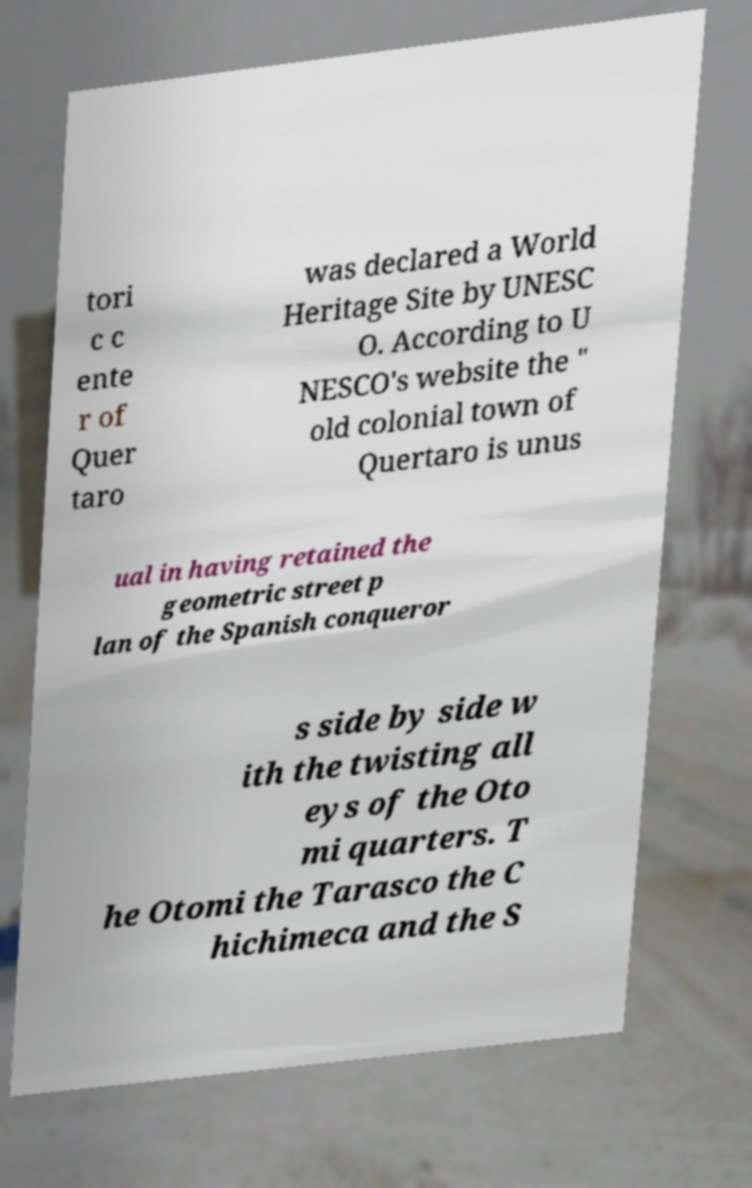I need the written content from this picture converted into text. Can you do that? tori c c ente r of Quer taro was declared a World Heritage Site by UNESC O. According to U NESCO's website the " old colonial town of Quertaro is unus ual in having retained the geometric street p lan of the Spanish conqueror s side by side w ith the twisting all eys of the Oto mi quarters. T he Otomi the Tarasco the C hichimeca and the S 